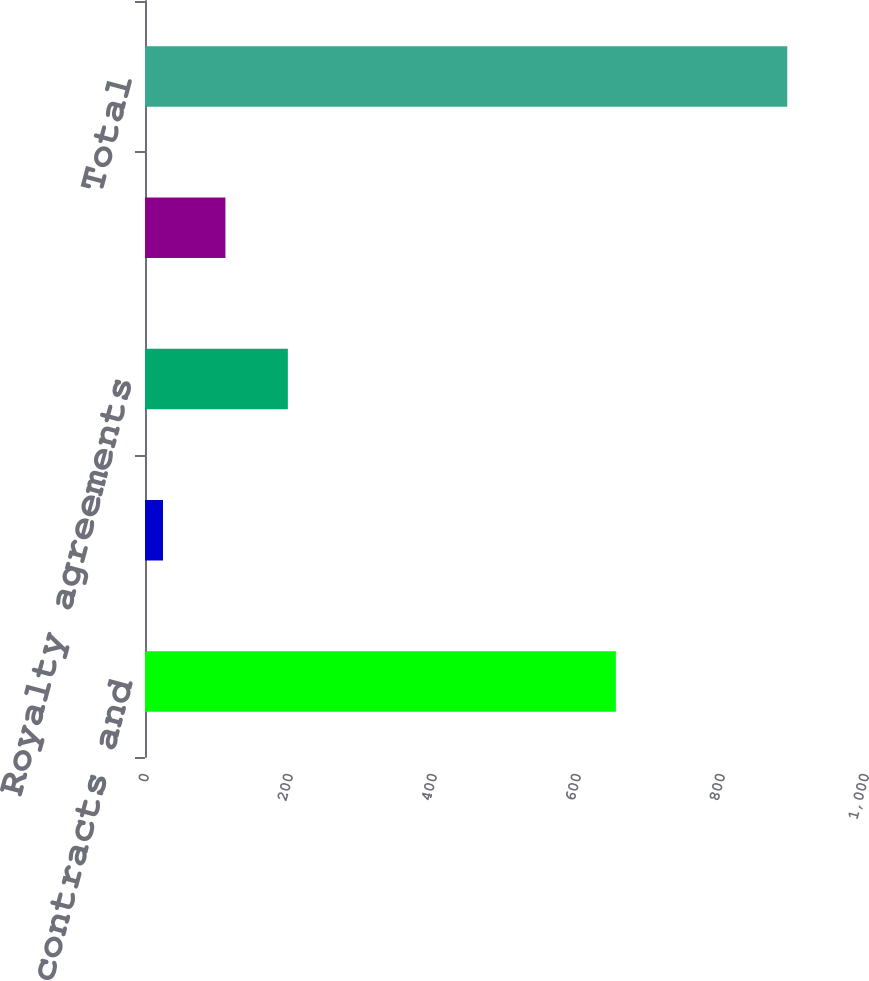Convert chart to OTSL. <chart><loc_0><loc_0><loc_500><loc_500><bar_chart><fcel>Customer contracts and<fcel>Brand rights and tradenames<fcel>Royalty agreements<fcel>Other<fcel>Total<nl><fcel>654<fcel>25<fcel>198.4<fcel>111.7<fcel>892<nl></chart> 